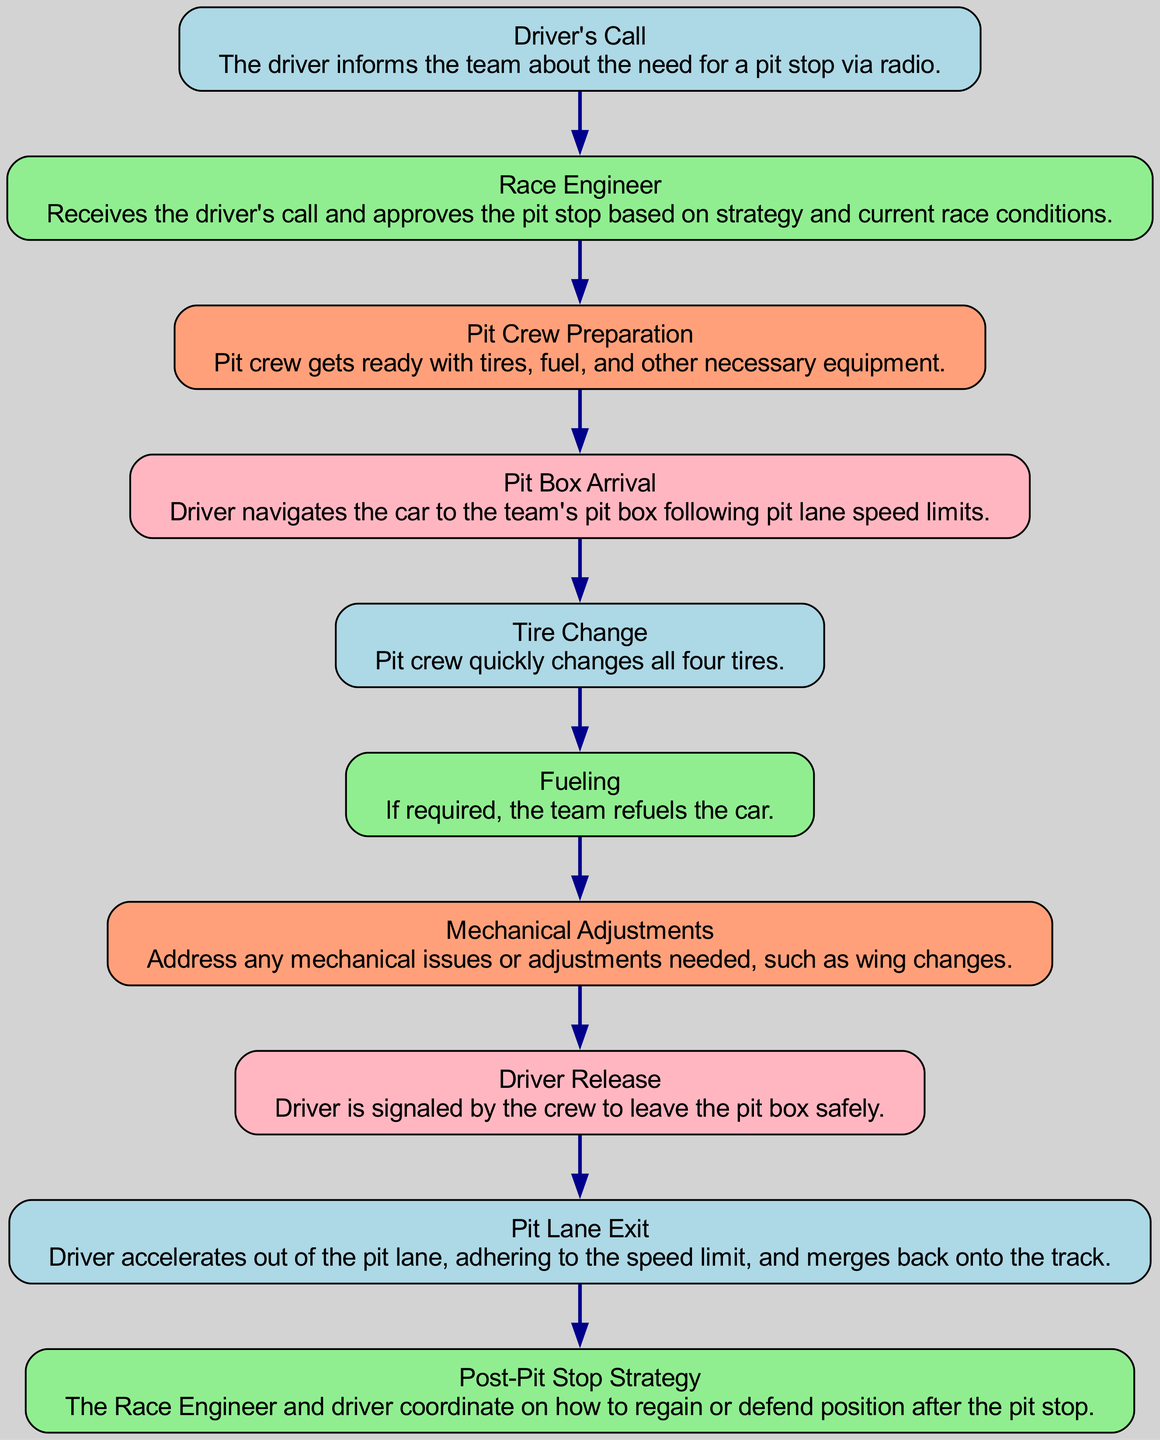What is the first step in the pit stop journey? The diagram starts with the "Driver's Call," which is the initial action taken when a driver communicates the need for a pit stop via radio.
Answer: Driver's Call How many elements are in the diagram? The diagram contains a total of ten elements that represent the different steps and roles involved in a pit stop.
Answer: 10 What action occurs after the Race Engineer's approval? Following the Race Engineer's approval, the next step is "Pit Crew Preparation," where the crew gets ready with necessary equipment.
Answer: Pit Crew Preparation Which step involves changing the car's tires? The "Tire Change" step specifically deals with the quick changing of all four tires by the pit crew during the pit stop.
Answer: Tire Change What is the last action before the car exits the pit lane? Before the car leaves the pit lane, the step "Driver Release" occurs, where the driver is signaled by the crew to depart safely.
Answer: Driver Release What happens after the Pit Box Arrival? After the "Pit Box Arrival," the driver undergoes the "Tire Change" process as part of the pit stop routine.
Answer: Tire Change How is the driver's strategy adjusted post-pit stop? After the pit stop, the "Post-Pit Stop Strategy" is coordinated between the Race Engineer and the driver to determine the best actions moving forward.
Answer: Post-Pit Stop Strategy What is the role of the Race Engineer during the pit stop? The Race Engineer receives the driver's call and makes decisions about the pit stop based on race strategy and conditions.
Answer: Approve the pit stop In what context does fueling occur? Fueling happens during the "Fueling" step, specifically when the team decides that refueling is necessary based on race strategy.
Answer: If required How does the driver rejoin the track after a pit stop? The driver accelerates out of the pit lane in the "Pit Lane Exit" step, ensuring compliance with speed limits while merging back onto the track.
Answer: Pit Lane Exit 